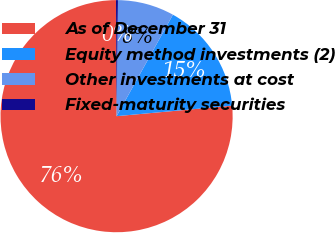<chart> <loc_0><loc_0><loc_500><loc_500><pie_chart><fcel>As of December 31<fcel>Equity method investments (2)<fcel>Other investments at cost<fcel>Fixed-maturity securities<nl><fcel>76.37%<fcel>15.49%<fcel>7.88%<fcel>0.27%<nl></chart> 